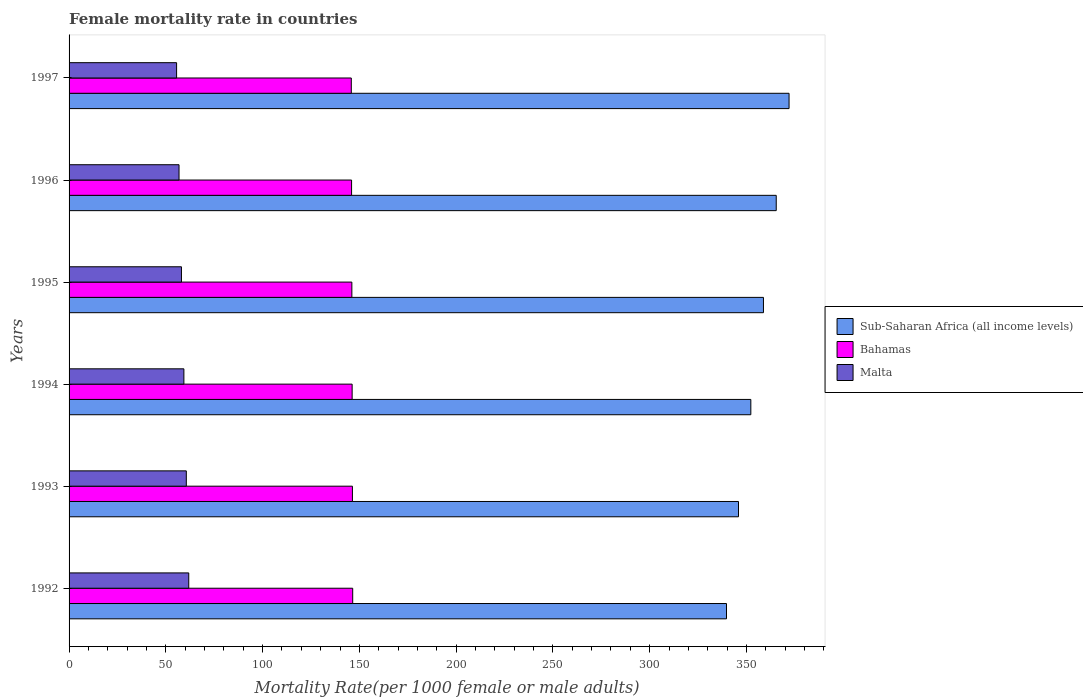How many groups of bars are there?
Ensure brevity in your answer.  6. Are the number of bars per tick equal to the number of legend labels?
Keep it short and to the point. Yes. Are the number of bars on each tick of the Y-axis equal?
Make the answer very short. Yes. How many bars are there on the 4th tick from the top?
Offer a terse response. 3. How many bars are there on the 1st tick from the bottom?
Offer a terse response. 3. What is the female mortality rate in Malta in 1993?
Your response must be concise. 60.58. Across all years, what is the maximum female mortality rate in Bahamas?
Provide a succinct answer. 146.55. Across all years, what is the minimum female mortality rate in Sub-Saharan Africa (all income levels)?
Your answer should be very brief. 339.69. In which year was the female mortality rate in Malta maximum?
Keep it short and to the point. 1992. In which year was the female mortality rate in Bahamas minimum?
Offer a very short reply. 1997. What is the total female mortality rate in Sub-Saharan Africa (all income levels) in the graph?
Give a very brief answer. 2134.04. What is the difference between the female mortality rate in Bahamas in 1992 and that in 1993?
Give a very brief answer. 0.14. What is the difference between the female mortality rate in Sub-Saharan Africa (all income levels) in 1992 and the female mortality rate in Malta in 1993?
Provide a succinct answer. 279.11. What is the average female mortality rate in Bahamas per year?
Keep it short and to the point. 146.19. In the year 1994, what is the difference between the female mortality rate in Bahamas and female mortality rate in Malta?
Your answer should be compact. 86.93. In how many years, is the female mortality rate in Malta greater than 90 ?
Offer a terse response. 0. What is the ratio of the female mortality rate in Bahamas in 1993 to that in 1994?
Offer a very short reply. 1. Is the female mortality rate in Bahamas in 1992 less than that in 1994?
Provide a succinct answer. No. Is the difference between the female mortality rate in Bahamas in 1994 and 1997 greater than the difference between the female mortality rate in Malta in 1994 and 1997?
Provide a succinct answer. No. What is the difference between the highest and the second highest female mortality rate in Bahamas?
Your answer should be very brief. 0.14. What is the difference between the highest and the lowest female mortality rate in Bahamas?
Your answer should be very brief. 0.73. What does the 3rd bar from the top in 1995 represents?
Ensure brevity in your answer.  Sub-Saharan Africa (all income levels). What does the 3rd bar from the bottom in 1992 represents?
Your answer should be very brief. Malta. How many bars are there?
Give a very brief answer. 18. Are all the bars in the graph horizontal?
Make the answer very short. Yes. What is the difference between two consecutive major ticks on the X-axis?
Make the answer very short. 50. How are the legend labels stacked?
Keep it short and to the point. Vertical. What is the title of the graph?
Offer a terse response. Female mortality rate in countries. Does "Macao" appear as one of the legend labels in the graph?
Offer a terse response. No. What is the label or title of the X-axis?
Make the answer very short. Mortality Rate(per 1000 female or male adults). What is the Mortality Rate(per 1000 female or male adults) in Sub-Saharan Africa (all income levels) in 1992?
Your answer should be very brief. 339.69. What is the Mortality Rate(per 1000 female or male adults) of Bahamas in 1992?
Your answer should be very brief. 146.55. What is the Mortality Rate(per 1000 female or male adults) of Malta in 1992?
Provide a short and direct response. 61.84. What is the Mortality Rate(per 1000 female or male adults) in Sub-Saharan Africa (all income levels) in 1993?
Your answer should be very brief. 345.89. What is the Mortality Rate(per 1000 female or male adults) of Bahamas in 1993?
Offer a very short reply. 146.41. What is the Mortality Rate(per 1000 female or male adults) of Malta in 1993?
Ensure brevity in your answer.  60.58. What is the Mortality Rate(per 1000 female or male adults) in Sub-Saharan Africa (all income levels) in 1994?
Keep it short and to the point. 352.26. What is the Mortality Rate(per 1000 female or male adults) of Bahamas in 1994?
Provide a succinct answer. 146.26. What is the Mortality Rate(per 1000 female or male adults) in Malta in 1994?
Give a very brief answer. 59.33. What is the Mortality Rate(per 1000 female or male adults) of Sub-Saharan Africa (all income levels) in 1995?
Make the answer very short. 358.79. What is the Mortality Rate(per 1000 female or male adults) in Bahamas in 1995?
Your answer should be compact. 146.11. What is the Mortality Rate(per 1000 female or male adults) in Malta in 1995?
Your answer should be compact. 58.07. What is the Mortality Rate(per 1000 female or male adults) of Sub-Saharan Africa (all income levels) in 1996?
Your answer should be compact. 365.39. What is the Mortality Rate(per 1000 female or male adults) in Bahamas in 1996?
Your answer should be very brief. 145.97. What is the Mortality Rate(per 1000 female or male adults) in Malta in 1996?
Offer a terse response. 56.81. What is the Mortality Rate(per 1000 female or male adults) of Sub-Saharan Africa (all income levels) in 1997?
Offer a very short reply. 372.01. What is the Mortality Rate(per 1000 female or male adults) of Bahamas in 1997?
Make the answer very short. 145.82. What is the Mortality Rate(per 1000 female or male adults) in Malta in 1997?
Provide a succinct answer. 55.56. Across all years, what is the maximum Mortality Rate(per 1000 female or male adults) in Sub-Saharan Africa (all income levels)?
Your answer should be very brief. 372.01. Across all years, what is the maximum Mortality Rate(per 1000 female or male adults) of Bahamas?
Ensure brevity in your answer.  146.55. Across all years, what is the maximum Mortality Rate(per 1000 female or male adults) of Malta?
Keep it short and to the point. 61.84. Across all years, what is the minimum Mortality Rate(per 1000 female or male adults) in Sub-Saharan Africa (all income levels)?
Your answer should be very brief. 339.69. Across all years, what is the minimum Mortality Rate(per 1000 female or male adults) of Bahamas?
Keep it short and to the point. 145.82. Across all years, what is the minimum Mortality Rate(per 1000 female or male adults) in Malta?
Provide a short and direct response. 55.56. What is the total Mortality Rate(per 1000 female or male adults) in Sub-Saharan Africa (all income levels) in the graph?
Make the answer very short. 2134.04. What is the total Mortality Rate(per 1000 female or male adults) in Bahamas in the graph?
Keep it short and to the point. 877.12. What is the total Mortality Rate(per 1000 female or male adults) of Malta in the graph?
Your answer should be compact. 352.19. What is the difference between the Mortality Rate(per 1000 female or male adults) of Sub-Saharan Africa (all income levels) in 1992 and that in 1993?
Make the answer very short. -6.2. What is the difference between the Mortality Rate(per 1000 female or male adults) of Bahamas in 1992 and that in 1993?
Your response must be concise. 0.14. What is the difference between the Mortality Rate(per 1000 female or male adults) of Malta in 1992 and that in 1993?
Provide a succinct answer. 1.26. What is the difference between the Mortality Rate(per 1000 female or male adults) of Sub-Saharan Africa (all income levels) in 1992 and that in 1994?
Give a very brief answer. -12.57. What is the difference between the Mortality Rate(per 1000 female or male adults) in Bahamas in 1992 and that in 1994?
Offer a terse response. 0.29. What is the difference between the Mortality Rate(per 1000 female or male adults) in Malta in 1992 and that in 1994?
Give a very brief answer. 2.51. What is the difference between the Mortality Rate(per 1000 female or male adults) in Sub-Saharan Africa (all income levels) in 1992 and that in 1995?
Your answer should be very brief. -19.1. What is the difference between the Mortality Rate(per 1000 female or male adults) in Bahamas in 1992 and that in 1995?
Ensure brevity in your answer.  0.44. What is the difference between the Mortality Rate(per 1000 female or male adults) of Malta in 1992 and that in 1995?
Offer a terse response. 3.77. What is the difference between the Mortality Rate(per 1000 female or male adults) of Sub-Saharan Africa (all income levels) in 1992 and that in 1996?
Make the answer very short. -25.7. What is the difference between the Mortality Rate(per 1000 female or male adults) in Bahamas in 1992 and that in 1996?
Provide a short and direct response. 0.58. What is the difference between the Mortality Rate(per 1000 female or male adults) in Malta in 1992 and that in 1996?
Make the answer very short. 5.02. What is the difference between the Mortality Rate(per 1000 female or male adults) in Sub-Saharan Africa (all income levels) in 1992 and that in 1997?
Your answer should be compact. -32.32. What is the difference between the Mortality Rate(per 1000 female or male adults) in Bahamas in 1992 and that in 1997?
Your answer should be very brief. 0.73. What is the difference between the Mortality Rate(per 1000 female or male adults) in Malta in 1992 and that in 1997?
Your answer should be compact. 6.28. What is the difference between the Mortality Rate(per 1000 female or male adults) in Sub-Saharan Africa (all income levels) in 1993 and that in 1994?
Give a very brief answer. -6.37. What is the difference between the Mortality Rate(per 1000 female or male adults) in Bahamas in 1993 and that in 1994?
Your answer should be very brief. 0.15. What is the difference between the Mortality Rate(per 1000 female or male adults) in Malta in 1993 and that in 1994?
Your answer should be very brief. 1.26. What is the difference between the Mortality Rate(per 1000 female or male adults) of Sub-Saharan Africa (all income levels) in 1993 and that in 1995?
Keep it short and to the point. -12.89. What is the difference between the Mortality Rate(per 1000 female or male adults) in Bahamas in 1993 and that in 1995?
Your answer should be very brief. 0.29. What is the difference between the Mortality Rate(per 1000 female or male adults) in Malta in 1993 and that in 1995?
Offer a terse response. 2.51. What is the difference between the Mortality Rate(per 1000 female or male adults) in Sub-Saharan Africa (all income levels) in 1993 and that in 1996?
Provide a succinct answer. -19.5. What is the difference between the Mortality Rate(per 1000 female or male adults) of Bahamas in 1993 and that in 1996?
Offer a terse response. 0.44. What is the difference between the Mortality Rate(per 1000 female or male adults) in Malta in 1993 and that in 1996?
Your answer should be compact. 3.77. What is the difference between the Mortality Rate(per 1000 female or male adults) in Sub-Saharan Africa (all income levels) in 1993 and that in 1997?
Ensure brevity in your answer.  -26.12. What is the difference between the Mortality Rate(per 1000 female or male adults) of Bahamas in 1993 and that in 1997?
Ensure brevity in your answer.  0.58. What is the difference between the Mortality Rate(per 1000 female or male adults) of Malta in 1993 and that in 1997?
Offer a very short reply. 5.02. What is the difference between the Mortality Rate(per 1000 female or male adults) in Sub-Saharan Africa (all income levels) in 1994 and that in 1995?
Make the answer very short. -6.52. What is the difference between the Mortality Rate(per 1000 female or male adults) of Bahamas in 1994 and that in 1995?
Provide a short and direct response. 0.15. What is the difference between the Mortality Rate(per 1000 female or male adults) of Malta in 1994 and that in 1995?
Offer a terse response. 1.26. What is the difference between the Mortality Rate(per 1000 female or male adults) of Sub-Saharan Africa (all income levels) in 1994 and that in 1996?
Keep it short and to the point. -13.13. What is the difference between the Mortality Rate(per 1000 female or male adults) in Bahamas in 1994 and that in 1996?
Your answer should be very brief. 0.29. What is the difference between the Mortality Rate(per 1000 female or male adults) of Malta in 1994 and that in 1996?
Your response must be concise. 2.51. What is the difference between the Mortality Rate(per 1000 female or male adults) in Sub-Saharan Africa (all income levels) in 1994 and that in 1997?
Provide a short and direct response. -19.75. What is the difference between the Mortality Rate(per 1000 female or male adults) of Bahamas in 1994 and that in 1997?
Provide a short and direct response. 0.44. What is the difference between the Mortality Rate(per 1000 female or male adults) in Malta in 1994 and that in 1997?
Your answer should be very brief. 3.77. What is the difference between the Mortality Rate(per 1000 female or male adults) in Sub-Saharan Africa (all income levels) in 1995 and that in 1996?
Offer a very short reply. -6.6. What is the difference between the Mortality Rate(per 1000 female or male adults) in Bahamas in 1995 and that in 1996?
Your answer should be very brief. 0.15. What is the difference between the Mortality Rate(per 1000 female or male adults) in Malta in 1995 and that in 1996?
Ensure brevity in your answer.  1.26. What is the difference between the Mortality Rate(per 1000 female or male adults) in Sub-Saharan Africa (all income levels) in 1995 and that in 1997?
Your answer should be very brief. -13.23. What is the difference between the Mortality Rate(per 1000 female or male adults) of Bahamas in 1995 and that in 1997?
Offer a very short reply. 0.29. What is the difference between the Mortality Rate(per 1000 female or male adults) in Malta in 1995 and that in 1997?
Ensure brevity in your answer.  2.51. What is the difference between the Mortality Rate(per 1000 female or male adults) in Sub-Saharan Africa (all income levels) in 1996 and that in 1997?
Your response must be concise. -6.62. What is the difference between the Mortality Rate(per 1000 female or male adults) in Bahamas in 1996 and that in 1997?
Provide a short and direct response. 0.15. What is the difference between the Mortality Rate(per 1000 female or male adults) of Malta in 1996 and that in 1997?
Ensure brevity in your answer.  1.26. What is the difference between the Mortality Rate(per 1000 female or male adults) in Sub-Saharan Africa (all income levels) in 1992 and the Mortality Rate(per 1000 female or male adults) in Bahamas in 1993?
Your answer should be very brief. 193.29. What is the difference between the Mortality Rate(per 1000 female or male adults) in Sub-Saharan Africa (all income levels) in 1992 and the Mortality Rate(per 1000 female or male adults) in Malta in 1993?
Offer a very short reply. 279.11. What is the difference between the Mortality Rate(per 1000 female or male adults) in Bahamas in 1992 and the Mortality Rate(per 1000 female or male adults) in Malta in 1993?
Your answer should be compact. 85.97. What is the difference between the Mortality Rate(per 1000 female or male adults) of Sub-Saharan Africa (all income levels) in 1992 and the Mortality Rate(per 1000 female or male adults) of Bahamas in 1994?
Your response must be concise. 193.43. What is the difference between the Mortality Rate(per 1000 female or male adults) of Sub-Saharan Africa (all income levels) in 1992 and the Mortality Rate(per 1000 female or male adults) of Malta in 1994?
Your response must be concise. 280.37. What is the difference between the Mortality Rate(per 1000 female or male adults) in Bahamas in 1992 and the Mortality Rate(per 1000 female or male adults) in Malta in 1994?
Offer a terse response. 87.23. What is the difference between the Mortality Rate(per 1000 female or male adults) of Sub-Saharan Africa (all income levels) in 1992 and the Mortality Rate(per 1000 female or male adults) of Bahamas in 1995?
Make the answer very short. 193.58. What is the difference between the Mortality Rate(per 1000 female or male adults) in Sub-Saharan Africa (all income levels) in 1992 and the Mortality Rate(per 1000 female or male adults) in Malta in 1995?
Your answer should be compact. 281.62. What is the difference between the Mortality Rate(per 1000 female or male adults) of Bahamas in 1992 and the Mortality Rate(per 1000 female or male adults) of Malta in 1995?
Provide a succinct answer. 88.48. What is the difference between the Mortality Rate(per 1000 female or male adults) in Sub-Saharan Africa (all income levels) in 1992 and the Mortality Rate(per 1000 female or male adults) in Bahamas in 1996?
Offer a terse response. 193.72. What is the difference between the Mortality Rate(per 1000 female or male adults) in Sub-Saharan Africa (all income levels) in 1992 and the Mortality Rate(per 1000 female or male adults) in Malta in 1996?
Offer a terse response. 282.88. What is the difference between the Mortality Rate(per 1000 female or male adults) of Bahamas in 1992 and the Mortality Rate(per 1000 female or male adults) of Malta in 1996?
Your answer should be compact. 89.74. What is the difference between the Mortality Rate(per 1000 female or male adults) of Sub-Saharan Africa (all income levels) in 1992 and the Mortality Rate(per 1000 female or male adults) of Bahamas in 1997?
Your answer should be compact. 193.87. What is the difference between the Mortality Rate(per 1000 female or male adults) in Sub-Saharan Africa (all income levels) in 1992 and the Mortality Rate(per 1000 female or male adults) in Malta in 1997?
Your response must be concise. 284.14. What is the difference between the Mortality Rate(per 1000 female or male adults) in Bahamas in 1992 and the Mortality Rate(per 1000 female or male adults) in Malta in 1997?
Your response must be concise. 90.99. What is the difference between the Mortality Rate(per 1000 female or male adults) of Sub-Saharan Africa (all income levels) in 1993 and the Mortality Rate(per 1000 female or male adults) of Bahamas in 1994?
Your response must be concise. 199.63. What is the difference between the Mortality Rate(per 1000 female or male adults) of Sub-Saharan Africa (all income levels) in 1993 and the Mortality Rate(per 1000 female or male adults) of Malta in 1994?
Offer a terse response. 286.57. What is the difference between the Mortality Rate(per 1000 female or male adults) in Bahamas in 1993 and the Mortality Rate(per 1000 female or male adults) in Malta in 1994?
Provide a short and direct response. 87.08. What is the difference between the Mortality Rate(per 1000 female or male adults) in Sub-Saharan Africa (all income levels) in 1993 and the Mortality Rate(per 1000 female or male adults) in Bahamas in 1995?
Your response must be concise. 199.78. What is the difference between the Mortality Rate(per 1000 female or male adults) in Sub-Saharan Africa (all income levels) in 1993 and the Mortality Rate(per 1000 female or male adults) in Malta in 1995?
Your answer should be compact. 287.83. What is the difference between the Mortality Rate(per 1000 female or male adults) in Bahamas in 1993 and the Mortality Rate(per 1000 female or male adults) in Malta in 1995?
Provide a short and direct response. 88.34. What is the difference between the Mortality Rate(per 1000 female or male adults) in Sub-Saharan Africa (all income levels) in 1993 and the Mortality Rate(per 1000 female or male adults) in Bahamas in 1996?
Offer a terse response. 199.93. What is the difference between the Mortality Rate(per 1000 female or male adults) in Sub-Saharan Africa (all income levels) in 1993 and the Mortality Rate(per 1000 female or male adults) in Malta in 1996?
Your answer should be compact. 289.08. What is the difference between the Mortality Rate(per 1000 female or male adults) of Bahamas in 1993 and the Mortality Rate(per 1000 female or male adults) of Malta in 1996?
Provide a succinct answer. 89.59. What is the difference between the Mortality Rate(per 1000 female or male adults) in Sub-Saharan Africa (all income levels) in 1993 and the Mortality Rate(per 1000 female or male adults) in Bahamas in 1997?
Make the answer very short. 200.07. What is the difference between the Mortality Rate(per 1000 female or male adults) of Sub-Saharan Africa (all income levels) in 1993 and the Mortality Rate(per 1000 female or male adults) of Malta in 1997?
Offer a very short reply. 290.34. What is the difference between the Mortality Rate(per 1000 female or male adults) of Bahamas in 1993 and the Mortality Rate(per 1000 female or male adults) of Malta in 1997?
Give a very brief answer. 90.85. What is the difference between the Mortality Rate(per 1000 female or male adults) in Sub-Saharan Africa (all income levels) in 1994 and the Mortality Rate(per 1000 female or male adults) in Bahamas in 1995?
Your answer should be compact. 206.15. What is the difference between the Mortality Rate(per 1000 female or male adults) in Sub-Saharan Africa (all income levels) in 1994 and the Mortality Rate(per 1000 female or male adults) in Malta in 1995?
Offer a terse response. 294.2. What is the difference between the Mortality Rate(per 1000 female or male adults) of Bahamas in 1994 and the Mortality Rate(per 1000 female or male adults) of Malta in 1995?
Your answer should be very brief. 88.19. What is the difference between the Mortality Rate(per 1000 female or male adults) in Sub-Saharan Africa (all income levels) in 1994 and the Mortality Rate(per 1000 female or male adults) in Bahamas in 1996?
Make the answer very short. 206.3. What is the difference between the Mortality Rate(per 1000 female or male adults) of Sub-Saharan Africa (all income levels) in 1994 and the Mortality Rate(per 1000 female or male adults) of Malta in 1996?
Ensure brevity in your answer.  295.45. What is the difference between the Mortality Rate(per 1000 female or male adults) of Bahamas in 1994 and the Mortality Rate(per 1000 female or male adults) of Malta in 1996?
Your response must be concise. 89.45. What is the difference between the Mortality Rate(per 1000 female or male adults) in Sub-Saharan Africa (all income levels) in 1994 and the Mortality Rate(per 1000 female or male adults) in Bahamas in 1997?
Offer a very short reply. 206.44. What is the difference between the Mortality Rate(per 1000 female or male adults) of Sub-Saharan Africa (all income levels) in 1994 and the Mortality Rate(per 1000 female or male adults) of Malta in 1997?
Provide a succinct answer. 296.71. What is the difference between the Mortality Rate(per 1000 female or male adults) in Bahamas in 1994 and the Mortality Rate(per 1000 female or male adults) in Malta in 1997?
Your response must be concise. 90.7. What is the difference between the Mortality Rate(per 1000 female or male adults) of Sub-Saharan Africa (all income levels) in 1995 and the Mortality Rate(per 1000 female or male adults) of Bahamas in 1996?
Your response must be concise. 212.82. What is the difference between the Mortality Rate(per 1000 female or male adults) of Sub-Saharan Africa (all income levels) in 1995 and the Mortality Rate(per 1000 female or male adults) of Malta in 1996?
Offer a terse response. 301.97. What is the difference between the Mortality Rate(per 1000 female or male adults) of Bahamas in 1995 and the Mortality Rate(per 1000 female or male adults) of Malta in 1996?
Provide a short and direct response. 89.3. What is the difference between the Mortality Rate(per 1000 female or male adults) of Sub-Saharan Africa (all income levels) in 1995 and the Mortality Rate(per 1000 female or male adults) of Bahamas in 1997?
Make the answer very short. 212.97. What is the difference between the Mortality Rate(per 1000 female or male adults) in Sub-Saharan Africa (all income levels) in 1995 and the Mortality Rate(per 1000 female or male adults) in Malta in 1997?
Ensure brevity in your answer.  303.23. What is the difference between the Mortality Rate(per 1000 female or male adults) in Bahamas in 1995 and the Mortality Rate(per 1000 female or male adults) in Malta in 1997?
Make the answer very short. 90.56. What is the difference between the Mortality Rate(per 1000 female or male adults) in Sub-Saharan Africa (all income levels) in 1996 and the Mortality Rate(per 1000 female or male adults) in Bahamas in 1997?
Make the answer very short. 219.57. What is the difference between the Mortality Rate(per 1000 female or male adults) of Sub-Saharan Africa (all income levels) in 1996 and the Mortality Rate(per 1000 female or male adults) of Malta in 1997?
Keep it short and to the point. 309.83. What is the difference between the Mortality Rate(per 1000 female or male adults) of Bahamas in 1996 and the Mortality Rate(per 1000 female or male adults) of Malta in 1997?
Give a very brief answer. 90.41. What is the average Mortality Rate(per 1000 female or male adults) of Sub-Saharan Africa (all income levels) per year?
Ensure brevity in your answer.  355.67. What is the average Mortality Rate(per 1000 female or male adults) in Bahamas per year?
Offer a very short reply. 146.19. What is the average Mortality Rate(per 1000 female or male adults) of Malta per year?
Make the answer very short. 58.7. In the year 1992, what is the difference between the Mortality Rate(per 1000 female or male adults) of Sub-Saharan Africa (all income levels) and Mortality Rate(per 1000 female or male adults) of Bahamas?
Keep it short and to the point. 193.14. In the year 1992, what is the difference between the Mortality Rate(per 1000 female or male adults) in Sub-Saharan Africa (all income levels) and Mortality Rate(per 1000 female or male adults) in Malta?
Your answer should be very brief. 277.85. In the year 1992, what is the difference between the Mortality Rate(per 1000 female or male adults) in Bahamas and Mortality Rate(per 1000 female or male adults) in Malta?
Your answer should be very brief. 84.71. In the year 1993, what is the difference between the Mortality Rate(per 1000 female or male adults) in Sub-Saharan Africa (all income levels) and Mortality Rate(per 1000 female or male adults) in Bahamas?
Provide a short and direct response. 199.49. In the year 1993, what is the difference between the Mortality Rate(per 1000 female or male adults) in Sub-Saharan Africa (all income levels) and Mortality Rate(per 1000 female or male adults) in Malta?
Provide a short and direct response. 285.31. In the year 1993, what is the difference between the Mortality Rate(per 1000 female or male adults) of Bahamas and Mortality Rate(per 1000 female or male adults) of Malta?
Offer a very short reply. 85.82. In the year 1994, what is the difference between the Mortality Rate(per 1000 female or male adults) of Sub-Saharan Africa (all income levels) and Mortality Rate(per 1000 female or male adults) of Bahamas?
Your response must be concise. 206. In the year 1994, what is the difference between the Mortality Rate(per 1000 female or male adults) of Sub-Saharan Africa (all income levels) and Mortality Rate(per 1000 female or male adults) of Malta?
Your answer should be very brief. 292.94. In the year 1994, what is the difference between the Mortality Rate(per 1000 female or male adults) of Bahamas and Mortality Rate(per 1000 female or male adults) of Malta?
Give a very brief answer. 86.93. In the year 1995, what is the difference between the Mortality Rate(per 1000 female or male adults) of Sub-Saharan Africa (all income levels) and Mortality Rate(per 1000 female or male adults) of Bahamas?
Your response must be concise. 212.67. In the year 1995, what is the difference between the Mortality Rate(per 1000 female or male adults) in Sub-Saharan Africa (all income levels) and Mortality Rate(per 1000 female or male adults) in Malta?
Offer a very short reply. 300.72. In the year 1995, what is the difference between the Mortality Rate(per 1000 female or male adults) in Bahamas and Mortality Rate(per 1000 female or male adults) in Malta?
Make the answer very short. 88.04. In the year 1996, what is the difference between the Mortality Rate(per 1000 female or male adults) of Sub-Saharan Africa (all income levels) and Mortality Rate(per 1000 female or male adults) of Bahamas?
Your answer should be compact. 219.42. In the year 1996, what is the difference between the Mortality Rate(per 1000 female or male adults) in Sub-Saharan Africa (all income levels) and Mortality Rate(per 1000 female or male adults) in Malta?
Give a very brief answer. 308.58. In the year 1996, what is the difference between the Mortality Rate(per 1000 female or male adults) of Bahamas and Mortality Rate(per 1000 female or male adults) of Malta?
Offer a very short reply. 89.15. In the year 1997, what is the difference between the Mortality Rate(per 1000 female or male adults) in Sub-Saharan Africa (all income levels) and Mortality Rate(per 1000 female or male adults) in Bahamas?
Ensure brevity in your answer.  226.19. In the year 1997, what is the difference between the Mortality Rate(per 1000 female or male adults) in Sub-Saharan Africa (all income levels) and Mortality Rate(per 1000 female or male adults) in Malta?
Offer a very short reply. 316.46. In the year 1997, what is the difference between the Mortality Rate(per 1000 female or male adults) in Bahamas and Mortality Rate(per 1000 female or male adults) in Malta?
Offer a terse response. 90.27. What is the ratio of the Mortality Rate(per 1000 female or male adults) of Sub-Saharan Africa (all income levels) in 1992 to that in 1993?
Provide a short and direct response. 0.98. What is the ratio of the Mortality Rate(per 1000 female or male adults) in Malta in 1992 to that in 1993?
Keep it short and to the point. 1.02. What is the ratio of the Mortality Rate(per 1000 female or male adults) of Sub-Saharan Africa (all income levels) in 1992 to that in 1994?
Offer a very short reply. 0.96. What is the ratio of the Mortality Rate(per 1000 female or male adults) of Bahamas in 1992 to that in 1994?
Keep it short and to the point. 1. What is the ratio of the Mortality Rate(per 1000 female or male adults) in Malta in 1992 to that in 1994?
Make the answer very short. 1.04. What is the ratio of the Mortality Rate(per 1000 female or male adults) of Sub-Saharan Africa (all income levels) in 1992 to that in 1995?
Offer a terse response. 0.95. What is the ratio of the Mortality Rate(per 1000 female or male adults) of Bahamas in 1992 to that in 1995?
Your response must be concise. 1. What is the ratio of the Mortality Rate(per 1000 female or male adults) of Malta in 1992 to that in 1995?
Make the answer very short. 1.06. What is the ratio of the Mortality Rate(per 1000 female or male adults) of Sub-Saharan Africa (all income levels) in 1992 to that in 1996?
Your answer should be very brief. 0.93. What is the ratio of the Mortality Rate(per 1000 female or male adults) in Bahamas in 1992 to that in 1996?
Provide a short and direct response. 1. What is the ratio of the Mortality Rate(per 1000 female or male adults) of Malta in 1992 to that in 1996?
Your answer should be very brief. 1.09. What is the ratio of the Mortality Rate(per 1000 female or male adults) of Sub-Saharan Africa (all income levels) in 1992 to that in 1997?
Keep it short and to the point. 0.91. What is the ratio of the Mortality Rate(per 1000 female or male adults) in Malta in 1992 to that in 1997?
Ensure brevity in your answer.  1.11. What is the ratio of the Mortality Rate(per 1000 female or male adults) of Sub-Saharan Africa (all income levels) in 1993 to that in 1994?
Give a very brief answer. 0.98. What is the ratio of the Mortality Rate(per 1000 female or male adults) of Bahamas in 1993 to that in 1994?
Make the answer very short. 1. What is the ratio of the Mortality Rate(per 1000 female or male adults) of Malta in 1993 to that in 1994?
Offer a terse response. 1.02. What is the ratio of the Mortality Rate(per 1000 female or male adults) of Sub-Saharan Africa (all income levels) in 1993 to that in 1995?
Your response must be concise. 0.96. What is the ratio of the Mortality Rate(per 1000 female or male adults) of Malta in 1993 to that in 1995?
Ensure brevity in your answer.  1.04. What is the ratio of the Mortality Rate(per 1000 female or male adults) of Sub-Saharan Africa (all income levels) in 1993 to that in 1996?
Keep it short and to the point. 0.95. What is the ratio of the Mortality Rate(per 1000 female or male adults) in Malta in 1993 to that in 1996?
Your answer should be compact. 1.07. What is the ratio of the Mortality Rate(per 1000 female or male adults) of Sub-Saharan Africa (all income levels) in 1993 to that in 1997?
Make the answer very short. 0.93. What is the ratio of the Mortality Rate(per 1000 female or male adults) in Malta in 1993 to that in 1997?
Ensure brevity in your answer.  1.09. What is the ratio of the Mortality Rate(per 1000 female or male adults) in Sub-Saharan Africa (all income levels) in 1994 to that in 1995?
Make the answer very short. 0.98. What is the ratio of the Mortality Rate(per 1000 female or male adults) in Bahamas in 1994 to that in 1995?
Keep it short and to the point. 1. What is the ratio of the Mortality Rate(per 1000 female or male adults) of Malta in 1994 to that in 1995?
Ensure brevity in your answer.  1.02. What is the ratio of the Mortality Rate(per 1000 female or male adults) of Sub-Saharan Africa (all income levels) in 1994 to that in 1996?
Offer a very short reply. 0.96. What is the ratio of the Mortality Rate(per 1000 female or male adults) of Malta in 1994 to that in 1996?
Provide a short and direct response. 1.04. What is the ratio of the Mortality Rate(per 1000 female or male adults) in Sub-Saharan Africa (all income levels) in 1994 to that in 1997?
Your response must be concise. 0.95. What is the ratio of the Mortality Rate(per 1000 female or male adults) of Bahamas in 1994 to that in 1997?
Offer a terse response. 1. What is the ratio of the Mortality Rate(per 1000 female or male adults) in Malta in 1994 to that in 1997?
Provide a succinct answer. 1.07. What is the ratio of the Mortality Rate(per 1000 female or male adults) in Sub-Saharan Africa (all income levels) in 1995 to that in 1996?
Give a very brief answer. 0.98. What is the ratio of the Mortality Rate(per 1000 female or male adults) in Bahamas in 1995 to that in 1996?
Keep it short and to the point. 1. What is the ratio of the Mortality Rate(per 1000 female or male adults) of Malta in 1995 to that in 1996?
Provide a succinct answer. 1.02. What is the ratio of the Mortality Rate(per 1000 female or male adults) of Sub-Saharan Africa (all income levels) in 1995 to that in 1997?
Your answer should be compact. 0.96. What is the ratio of the Mortality Rate(per 1000 female or male adults) in Malta in 1995 to that in 1997?
Offer a terse response. 1.05. What is the ratio of the Mortality Rate(per 1000 female or male adults) of Sub-Saharan Africa (all income levels) in 1996 to that in 1997?
Ensure brevity in your answer.  0.98. What is the ratio of the Mortality Rate(per 1000 female or male adults) in Bahamas in 1996 to that in 1997?
Ensure brevity in your answer.  1. What is the ratio of the Mortality Rate(per 1000 female or male adults) of Malta in 1996 to that in 1997?
Your answer should be compact. 1.02. What is the difference between the highest and the second highest Mortality Rate(per 1000 female or male adults) of Sub-Saharan Africa (all income levels)?
Ensure brevity in your answer.  6.62. What is the difference between the highest and the second highest Mortality Rate(per 1000 female or male adults) in Bahamas?
Offer a terse response. 0.14. What is the difference between the highest and the second highest Mortality Rate(per 1000 female or male adults) in Malta?
Give a very brief answer. 1.26. What is the difference between the highest and the lowest Mortality Rate(per 1000 female or male adults) in Sub-Saharan Africa (all income levels)?
Ensure brevity in your answer.  32.32. What is the difference between the highest and the lowest Mortality Rate(per 1000 female or male adults) in Bahamas?
Keep it short and to the point. 0.73. What is the difference between the highest and the lowest Mortality Rate(per 1000 female or male adults) in Malta?
Make the answer very short. 6.28. 